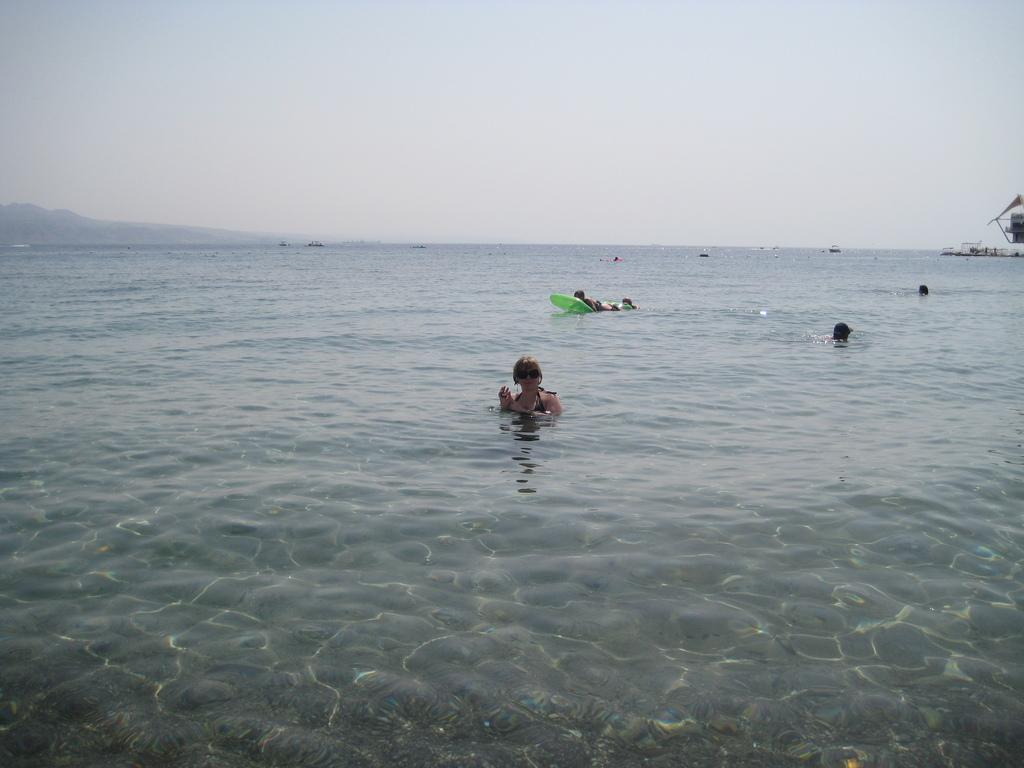What is present in the image? There is water and people in the image. What can be seen in the background of the image? The sky is visible in the background of the image. Where is the playground located in the image? There is no playground present in the image. What type of power is being generated by the water in the image? There is no indication of power generation in the image; it simply shows water and people. 